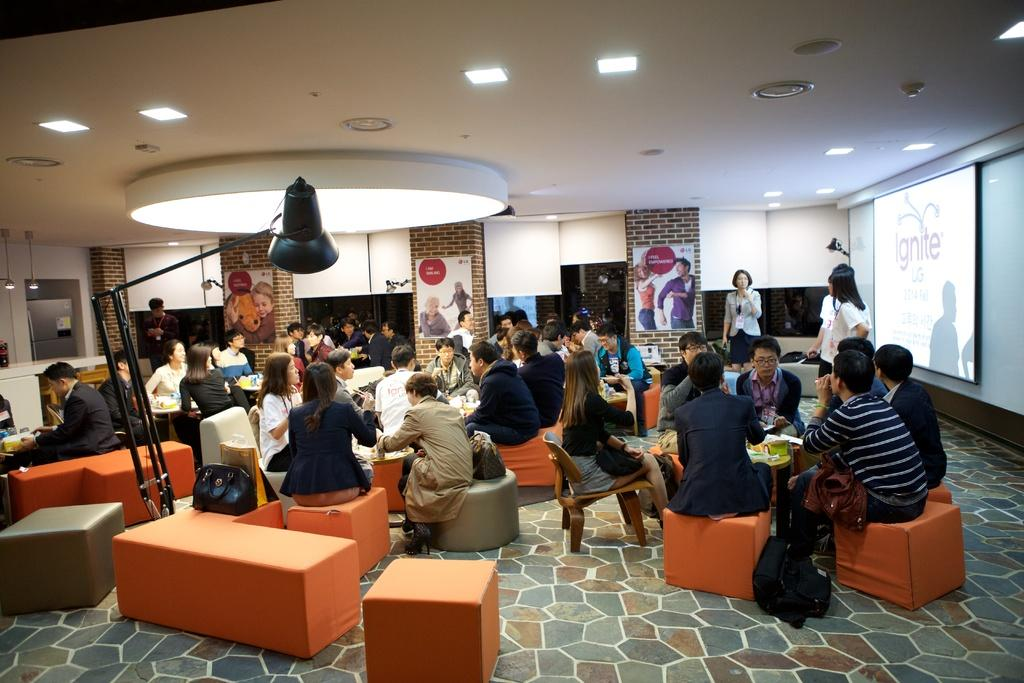How many types of seating can be seen in the image? There are two types of seating in the image: cube stools and chairs. What are the people in the image doing? The people in the image are sitting on cube stools and chairs. What type of lighting is present in the image? There are lamps and lights on the roof in the image. What is the purpose of the screen in the image? The purpose of the screen in the image is not specified, but it could be used for presentations or displays. What type of knife is being used by the laborer in the image? There is no laborer or knife present in the image. 